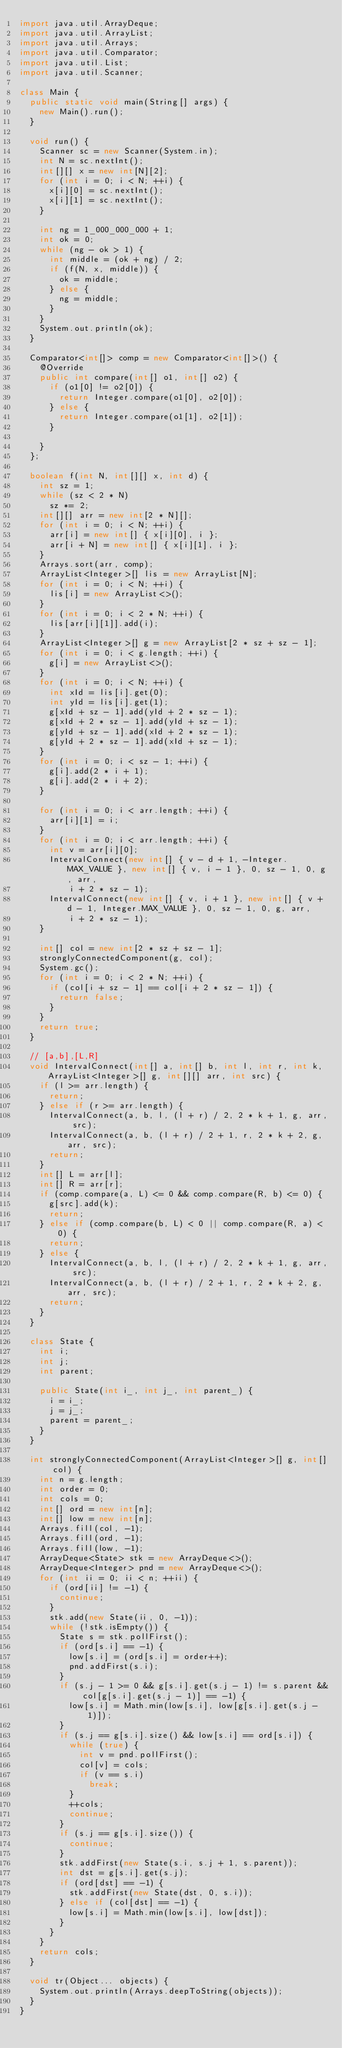Convert code to text. <code><loc_0><loc_0><loc_500><loc_500><_Java_>import java.util.ArrayDeque;
import java.util.ArrayList;
import java.util.Arrays;
import java.util.Comparator;
import java.util.List;
import java.util.Scanner;

class Main {
	public static void main(String[] args) {
		new Main().run();
	}

	void run() {
		Scanner sc = new Scanner(System.in);
		int N = sc.nextInt();
		int[][] x = new int[N][2];
		for (int i = 0; i < N; ++i) {
			x[i][0] = sc.nextInt();
			x[i][1] = sc.nextInt();
		}

		int ng = 1_000_000_000 + 1;
		int ok = 0;
		while (ng - ok > 1) {
			int middle = (ok + ng) / 2;
			if (f(N, x, middle)) {
				ok = middle;
			} else {
				ng = middle;
			}
		}
		System.out.println(ok);
	}

	Comparator<int[]> comp = new Comparator<int[]>() {
		@Override
		public int compare(int[] o1, int[] o2) {
			if (o1[0] != o2[0]) {
				return Integer.compare(o1[0], o2[0]);
			} else {
				return Integer.compare(o1[1], o2[1]);
			}

		}
	};

	boolean f(int N, int[][] x, int d) {
		int sz = 1;
		while (sz < 2 * N)
			sz *= 2;
		int[][] arr = new int[2 * N][];
		for (int i = 0; i < N; ++i) {
			arr[i] = new int[] { x[i][0], i };
			arr[i + N] = new int[] { x[i][1], i };
		}
		Arrays.sort(arr, comp);
		ArrayList<Integer>[] lis = new ArrayList[N];
		for (int i = 0; i < N; ++i) {
			lis[i] = new ArrayList<>();
		}
		for (int i = 0; i < 2 * N; ++i) {
			lis[arr[i][1]].add(i);
		}
		ArrayList<Integer>[] g = new ArrayList[2 * sz + sz - 1];
		for (int i = 0; i < g.length; ++i) {
			g[i] = new ArrayList<>();
		}
		for (int i = 0; i < N; ++i) {
			int xId = lis[i].get(0);
			int yId = lis[i].get(1);
			g[xId + sz - 1].add(yId + 2 * sz - 1);
			g[xId + 2 * sz - 1].add(yId + sz - 1);
			g[yId + sz - 1].add(xId + 2 * sz - 1);
			g[yId + 2 * sz - 1].add(xId + sz - 1);
		}
		for (int i = 0; i < sz - 1; ++i) {
			g[i].add(2 * i + 1);
			g[i].add(2 * i + 2);
		}

		for (int i = 0; i < arr.length; ++i) {
			arr[i][1] = i;
		}
		for (int i = 0; i < arr.length; ++i) {
			int v = arr[i][0];
			IntervalConnect(new int[] { v - d + 1, -Integer.MAX_VALUE }, new int[] { v, i - 1 }, 0, sz - 1, 0, g, arr,
					i + 2 * sz - 1);
			IntervalConnect(new int[] { v, i + 1 }, new int[] { v + d - 1, Integer.MAX_VALUE }, 0, sz - 1, 0, g, arr,
					i + 2 * sz - 1);
		}

		int[] col = new int[2 * sz + sz - 1];
		stronglyConnectedComponent(g, col);
		System.gc();
		for (int i = 0; i < 2 * N; ++i) {
			if (col[i + sz - 1] == col[i + 2 * sz - 1]) {
				return false;
			}
		}
		return true;
	}

	// [a,b],[L,R]
	void IntervalConnect(int[] a, int[] b, int l, int r, int k, ArrayList<Integer>[] g, int[][] arr, int src) {
		if (l >= arr.length) {
			return;
		} else if (r >= arr.length) {
			IntervalConnect(a, b, l, (l + r) / 2, 2 * k + 1, g, arr, src);
			IntervalConnect(a, b, (l + r) / 2 + 1, r, 2 * k + 2, g, arr, src);
			return;
		}
		int[] L = arr[l];
		int[] R = arr[r];
		if (comp.compare(a, L) <= 0 && comp.compare(R, b) <= 0) {
			g[src].add(k);
			return;
		} else if (comp.compare(b, L) < 0 || comp.compare(R, a) < 0) {
			return;
		} else {
			IntervalConnect(a, b, l, (l + r) / 2, 2 * k + 1, g, arr, src);
			IntervalConnect(a, b, (l + r) / 2 + 1, r, 2 * k + 2, g, arr, src);
			return;
		}
	}

	class State {
		int i;
		int j;
		int parent;

		public State(int i_, int j_, int parent_) {
			i = i_;
			j = j_;
			parent = parent_;
		}
	}

	int stronglyConnectedComponent(ArrayList<Integer>[] g, int[] col) {
		int n = g.length;
		int order = 0;
		int cols = 0;
		int[] ord = new int[n];
		int[] low = new int[n];
		Arrays.fill(col, -1);
		Arrays.fill(ord, -1);
		Arrays.fill(low, -1);
		ArrayDeque<State> stk = new ArrayDeque<>();
		ArrayDeque<Integer> pnd = new ArrayDeque<>();
		for (int ii = 0; ii < n; ++ii) {
			if (ord[ii] != -1) {
				continue;
			}
			stk.add(new State(ii, 0, -1));
			while (!stk.isEmpty()) {
				State s = stk.pollFirst();
				if (ord[s.i] == -1) {
					low[s.i] = (ord[s.i] = order++);
					pnd.addFirst(s.i);
				}
				if (s.j - 1 >= 0 && g[s.i].get(s.j - 1) != s.parent && col[g[s.i].get(s.j - 1)] == -1) {
					low[s.i] = Math.min(low[s.i], low[g[s.i].get(s.j - 1)]);
				}
				if (s.j == g[s.i].size() && low[s.i] == ord[s.i]) {
					while (true) {
						int v = pnd.pollFirst();
						col[v] = cols;
						if (v == s.i)
							break;
					}
					++cols;
					continue;
				}
				if (s.j == g[s.i].size()) {
					continue;
				}
				stk.addFirst(new State(s.i, s.j + 1, s.parent));
				int dst = g[s.i].get(s.j);
				if (ord[dst] == -1) {
					stk.addFirst(new State(dst, 0, s.i));
				} else if (col[dst] == -1) {
					low[s.i] = Math.min(low[s.i], low[dst]);
				}
			}
		}
		return cols;
	}

	void tr(Object... objects) {
		System.out.println(Arrays.deepToString(objects));
	}
}</code> 